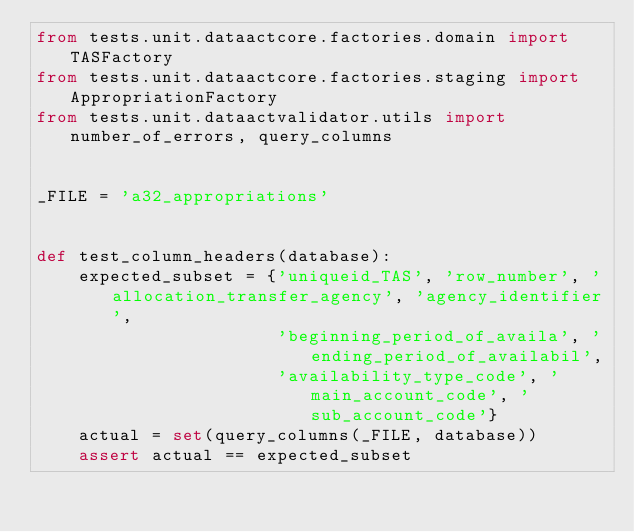<code> <loc_0><loc_0><loc_500><loc_500><_Python_>from tests.unit.dataactcore.factories.domain import TASFactory
from tests.unit.dataactcore.factories.staging import AppropriationFactory
from tests.unit.dataactvalidator.utils import number_of_errors, query_columns


_FILE = 'a32_appropriations'


def test_column_headers(database):
    expected_subset = {'uniqueid_TAS', 'row_number', 'allocation_transfer_agency', 'agency_identifier',
                       'beginning_period_of_availa', 'ending_period_of_availabil',
                       'availability_type_code', 'main_account_code', 'sub_account_code'}
    actual = set(query_columns(_FILE, database))
    assert actual == expected_subset

</code> 